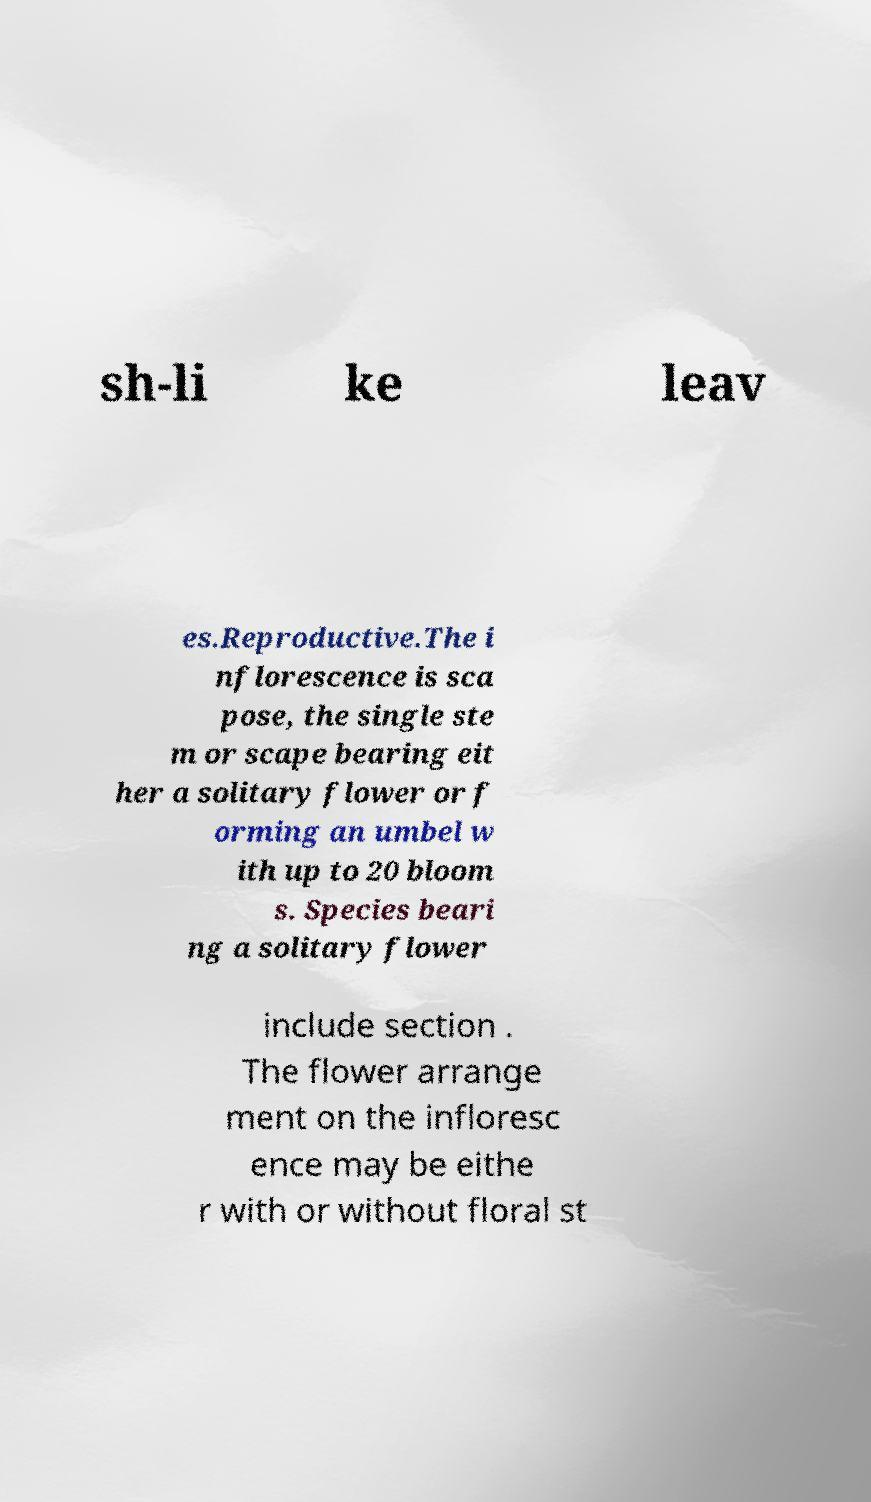I need the written content from this picture converted into text. Can you do that? sh-li ke leav es.Reproductive.The i nflorescence is sca pose, the single ste m or scape bearing eit her a solitary flower or f orming an umbel w ith up to 20 bloom s. Species beari ng a solitary flower include section . The flower arrange ment on the infloresc ence may be eithe r with or without floral st 